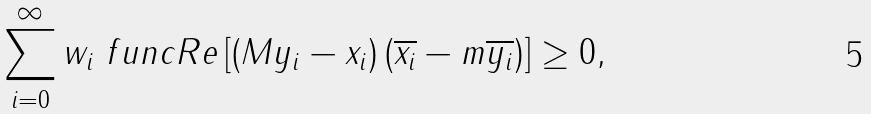Convert formula to latex. <formula><loc_0><loc_0><loc_500><loc_500>\sum _ { i = 0 } ^ { \infty } w _ { i } \ f u n c { R e } \left [ \left ( M y _ { i } - x _ { i } \right ) \left ( \overline { x _ { i } } - m \overline { y _ { i } } \right ) \right ] \geq 0 ,</formula> 